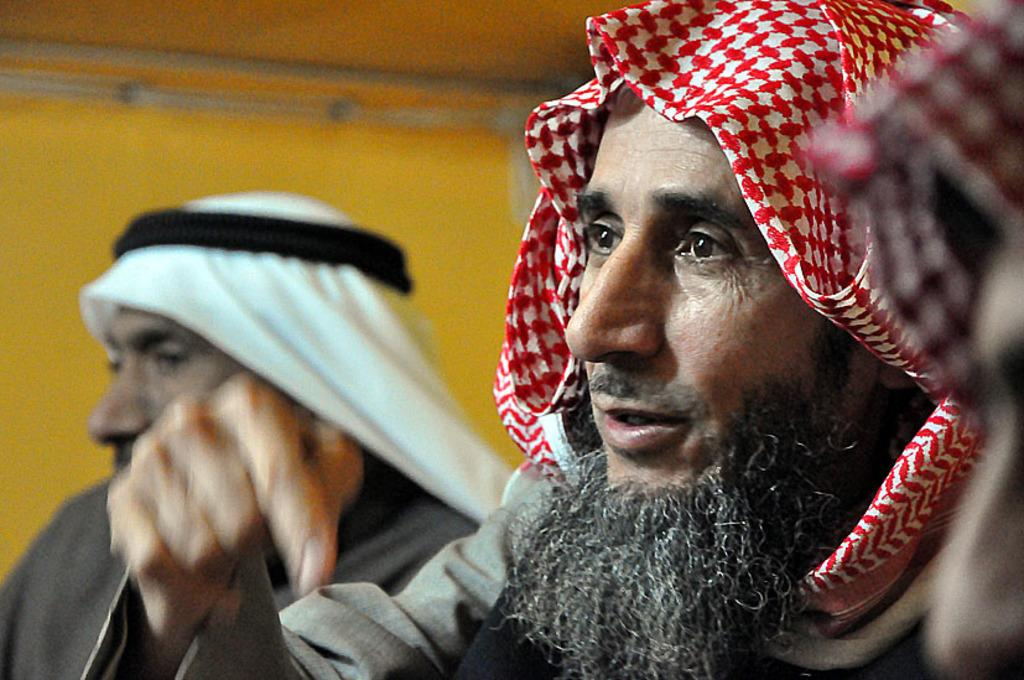How many people are in the image? There are two persons sitting in the image. What can be seen on the heads of the persons? The persons have a cloth on their heads. What color is the background wall in the image? The background wall is in yellow color. What type of hot dish is being served for dinner in the image? There is no hot dish or dinner being served in the image; it only shows two persons with a cloth on their heads and a yellow background wall. 